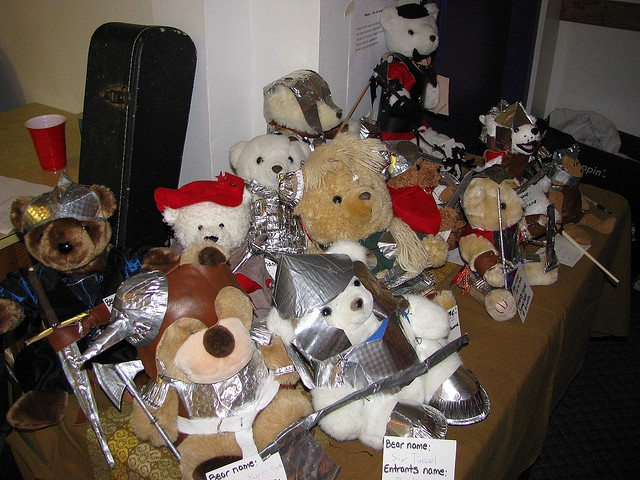Describe the objects in this image and their specific colors. I can see teddy bear in gray, lightgray, darkgray, and black tones, teddy bear in gray, tan, maroon, and lightgray tones, teddy bear in gray, black, and maroon tones, teddy bear in gray, tan, darkgray, and olive tones, and teddy bear in gray and black tones in this image. 